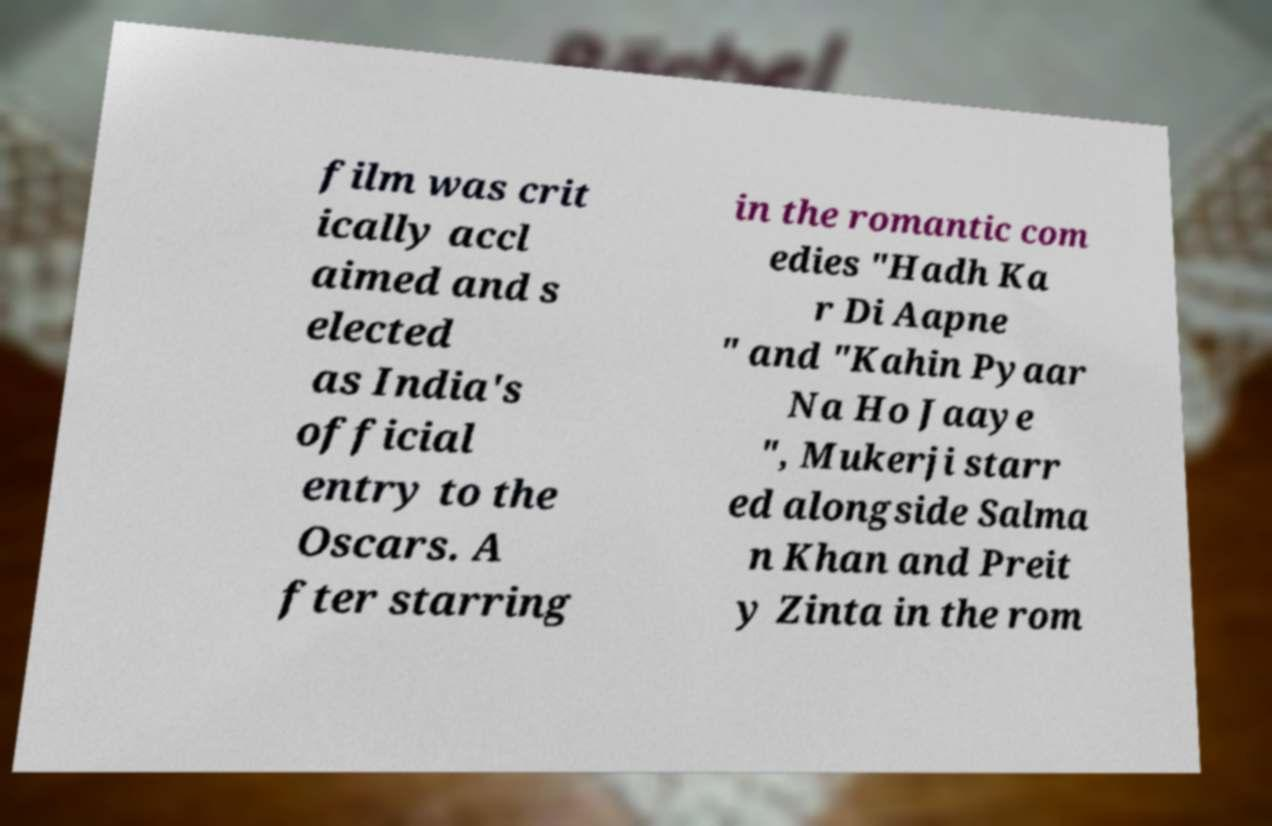Can you read and provide the text displayed in the image?This photo seems to have some interesting text. Can you extract and type it out for me? film was crit ically accl aimed and s elected as India's official entry to the Oscars. A fter starring in the romantic com edies "Hadh Ka r Di Aapne " and "Kahin Pyaar Na Ho Jaaye ", Mukerji starr ed alongside Salma n Khan and Preit y Zinta in the rom 